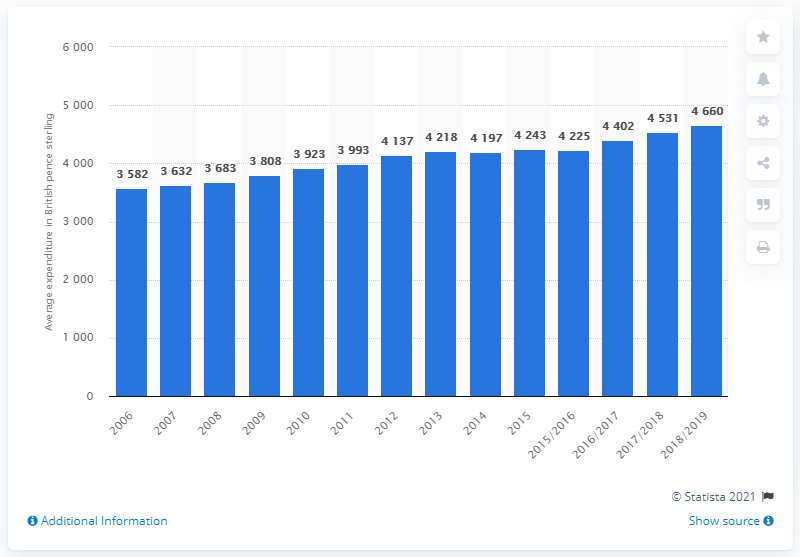Indicate a few pertinent items in this graphic. In the year 2006, the average expenditure per person per week on food and drink in the United Kingdom was recorded. 